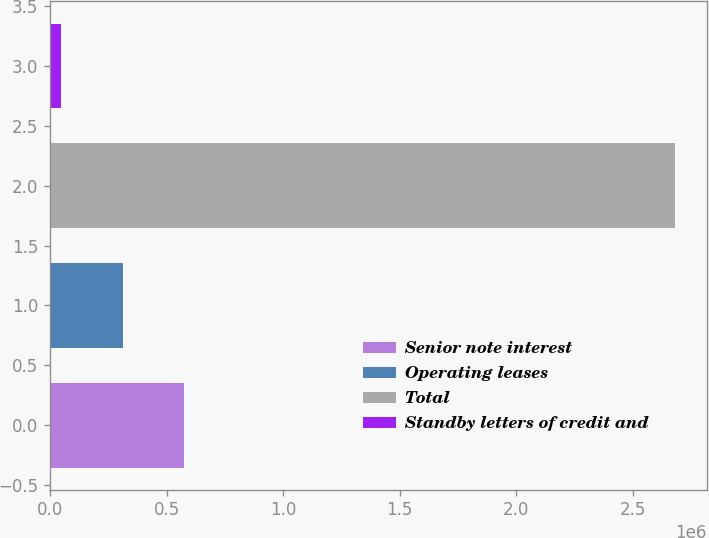Convert chart to OTSL. <chart><loc_0><loc_0><loc_500><loc_500><bar_chart><fcel>Senior note interest<fcel>Operating leases<fcel>Total<fcel>Standby letters of credit and<nl><fcel>575845<fcel>312390<fcel>2.68349e+06<fcel>48934<nl></chart> 